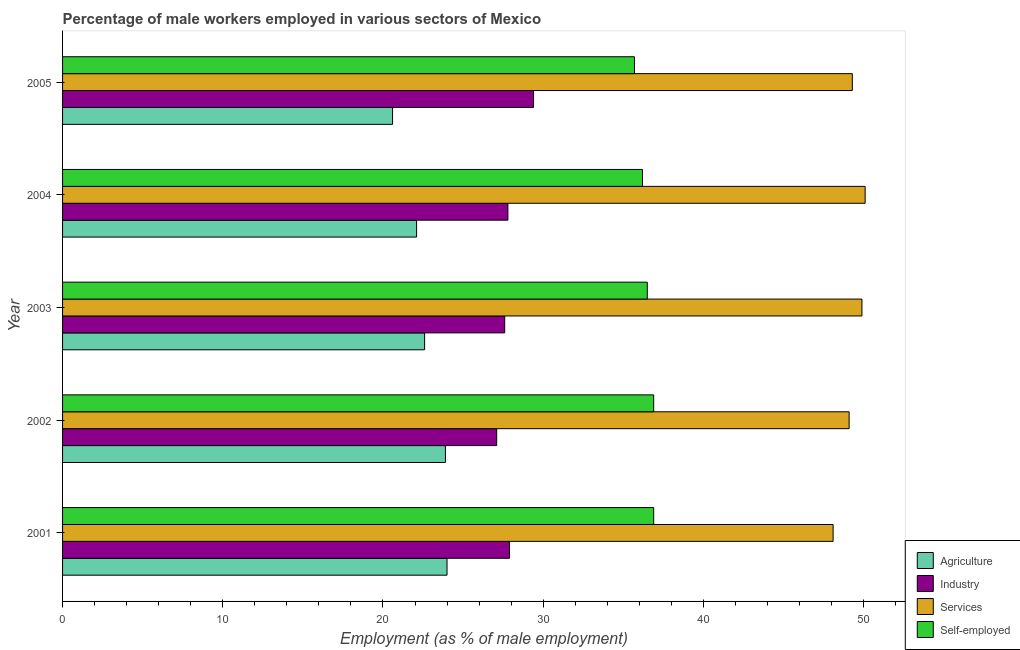How many groups of bars are there?
Provide a short and direct response. 5. Are the number of bars on each tick of the Y-axis equal?
Provide a succinct answer. Yes. What is the label of the 1st group of bars from the top?
Keep it short and to the point. 2005. What is the percentage of self employed male workers in 2004?
Make the answer very short. 36.2. Across all years, what is the minimum percentage of self employed male workers?
Your response must be concise. 35.7. In which year was the percentage of male workers in agriculture minimum?
Give a very brief answer. 2005. What is the total percentage of male workers in services in the graph?
Give a very brief answer. 246.5. What is the difference between the percentage of self employed male workers in 2001 and that in 2005?
Make the answer very short. 1.2. What is the difference between the percentage of male workers in industry in 2005 and the percentage of self employed male workers in 2004?
Offer a terse response. -6.8. What is the average percentage of self employed male workers per year?
Provide a succinct answer. 36.44. What is the ratio of the percentage of male workers in industry in 2001 to that in 2002?
Provide a succinct answer. 1.03. Is the percentage of male workers in services in 2003 less than that in 2004?
Your answer should be very brief. Yes. Is the difference between the percentage of male workers in services in 2001 and 2002 greater than the difference between the percentage of self employed male workers in 2001 and 2002?
Your response must be concise. No. What is the difference between the highest and the lowest percentage of male workers in services?
Your response must be concise. 2. In how many years, is the percentage of self employed male workers greater than the average percentage of self employed male workers taken over all years?
Give a very brief answer. 3. What does the 3rd bar from the top in 2001 represents?
Your answer should be very brief. Industry. What does the 1st bar from the bottom in 2003 represents?
Your answer should be very brief. Agriculture. Is it the case that in every year, the sum of the percentage of male workers in agriculture and percentage of male workers in industry is greater than the percentage of male workers in services?
Your response must be concise. No. Are all the bars in the graph horizontal?
Your answer should be very brief. Yes. Are the values on the major ticks of X-axis written in scientific E-notation?
Provide a short and direct response. No. Where does the legend appear in the graph?
Offer a very short reply. Bottom right. What is the title of the graph?
Ensure brevity in your answer.  Percentage of male workers employed in various sectors of Mexico. Does "Plant species" appear as one of the legend labels in the graph?
Keep it short and to the point. No. What is the label or title of the X-axis?
Offer a terse response. Employment (as % of male employment). What is the label or title of the Y-axis?
Your answer should be very brief. Year. What is the Employment (as % of male employment) in Agriculture in 2001?
Offer a very short reply. 24. What is the Employment (as % of male employment) in Industry in 2001?
Offer a terse response. 27.9. What is the Employment (as % of male employment) of Services in 2001?
Make the answer very short. 48.1. What is the Employment (as % of male employment) of Self-employed in 2001?
Provide a short and direct response. 36.9. What is the Employment (as % of male employment) in Agriculture in 2002?
Your answer should be very brief. 23.9. What is the Employment (as % of male employment) in Industry in 2002?
Provide a succinct answer. 27.1. What is the Employment (as % of male employment) in Services in 2002?
Ensure brevity in your answer.  49.1. What is the Employment (as % of male employment) in Self-employed in 2002?
Provide a succinct answer. 36.9. What is the Employment (as % of male employment) of Agriculture in 2003?
Give a very brief answer. 22.6. What is the Employment (as % of male employment) in Industry in 2003?
Make the answer very short. 27.6. What is the Employment (as % of male employment) in Services in 2003?
Keep it short and to the point. 49.9. What is the Employment (as % of male employment) of Self-employed in 2003?
Ensure brevity in your answer.  36.5. What is the Employment (as % of male employment) of Agriculture in 2004?
Your answer should be very brief. 22.1. What is the Employment (as % of male employment) in Industry in 2004?
Ensure brevity in your answer.  27.8. What is the Employment (as % of male employment) of Services in 2004?
Your response must be concise. 50.1. What is the Employment (as % of male employment) of Self-employed in 2004?
Your response must be concise. 36.2. What is the Employment (as % of male employment) in Agriculture in 2005?
Keep it short and to the point. 20.6. What is the Employment (as % of male employment) in Industry in 2005?
Your answer should be compact. 29.4. What is the Employment (as % of male employment) in Services in 2005?
Your answer should be compact. 49.3. What is the Employment (as % of male employment) in Self-employed in 2005?
Provide a succinct answer. 35.7. Across all years, what is the maximum Employment (as % of male employment) in Industry?
Offer a terse response. 29.4. Across all years, what is the maximum Employment (as % of male employment) in Services?
Your answer should be compact. 50.1. Across all years, what is the maximum Employment (as % of male employment) of Self-employed?
Provide a short and direct response. 36.9. Across all years, what is the minimum Employment (as % of male employment) of Agriculture?
Offer a terse response. 20.6. Across all years, what is the minimum Employment (as % of male employment) of Industry?
Give a very brief answer. 27.1. Across all years, what is the minimum Employment (as % of male employment) of Services?
Make the answer very short. 48.1. Across all years, what is the minimum Employment (as % of male employment) of Self-employed?
Make the answer very short. 35.7. What is the total Employment (as % of male employment) in Agriculture in the graph?
Keep it short and to the point. 113.2. What is the total Employment (as % of male employment) of Industry in the graph?
Give a very brief answer. 139.8. What is the total Employment (as % of male employment) in Services in the graph?
Your response must be concise. 246.5. What is the total Employment (as % of male employment) of Self-employed in the graph?
Keep it short and to the point. 182.2. What is the difference between the Employment (as % of male employment) in Agriculture in 2001 and that in 2002?
Keep it short and to the point. 0.1. What is the difference between the Employment (as % of male employment) in Services in 2001 and that in 2002?
Make the answer very short. -1. What is the difference between the Employment (as % of male employment) of Self-employed in 2001 and that in 2002?
Offer a terse response. 0. What is the difference between the Employment (as % of male employment) in Industry in 2001 and that in 2003?
Make the answer very short. 0.3. What is the difference between the Employment (as % of male employment) in Services in 2001 and that in 2003?
Offer a terse response. -1.8. What is the difference between the Employment (as % of male employment) in Self-employed in 2001 and that in 2004?
Make the answer very short. 0.7. What is the difference between the Employment (as % of male employment) in Agriculture in 2001 and that in 2005?
Offer a very short reply. 3.4. What is the difference between the Employment (as % of male employment) of Industry in 2001 and that in 2005?
Keep it short and to the point. -1.5. What is the difference between the Employment (as % of male employment) of Services in 2001 and that in 2005?
Provide a short and direct response. -1.2. What is the difference between the Employment (as % of male employment) in Self-employed in 2001 and that in 2005?
Offer a terse response. 1.2. What is the difference between the Employment (as % of male employment) of Agriculture in 2002 and that in 2003?
Offer a terse response. 1.3. What is the difference between the Employment (as % of male employment) in Services in 2002 and that in 2003?
Provide a succinct answer. -0.8. What is the difference between the Employment (as % of male employment) in Self-employed in 2002 and that in 2004?
Your answer should be compact. 0.7. What is the difference between the Employment (as % of male employment) of Industry in 2002 and that in 2005?
Your response must be concise. -2.3. What is the difference between the Employment (as % of male employment) in Self-employed in 2002 and that in 2005?
Give a very brief answer. 1.2. What is the difference between the Employment (as % of male employment) in Industry in 2003 and that in 2004?
Provide a short and direct response. -0.2. What is the difference between the Employment (as % of male employment) in Services in 2003 and that in 2004?
Provide a short and direct response. -0.2. What is the difference between the Employment (as % of male employment) of Self-employed in 2003 and that in 2004?
Your answer should be compact. 0.3. What is the difference between the Employment (as % of male employment) of Agriculture in 2003 and that in 2005?
Your response must be concise. 2. What is the difference between the Employment (as % of male employment) of Self-employed in 2003 and that in 2005?
Make the answer very short. 0.8. What is the difference between the Employment (as % of male employment) in Agriculture in 2004 and that in 2005?
Make the answer very short. 1.5. What is the difference between the Employment (as % of male employment) in Industry in 2004 and that in 2005?
Provide a short and direct response. -1.6. What is the difference between the Employment (as % of male employment) in Self-employed in 2004 and that in 2005?
Your answer should be compact. 0.5. What is the difference between the Employment (as % of male employment) of Agriculture in 2001 and the Employment (as % of male employment) of Services in 2002?
Offer a terse response. -25.1. What is the difference between the Employment (as % of male employment) of Agriculture in 2001 and the Employment (as % of male employment) of Self-employed in 2002?
Your response must be concise. -12.9. What is the difference between the Employment (as % of male employment) in Industry in 2001 and the Employment (as % of male employment) in Services in 2002?
Keep it short and to the point. -21.2. What is the difference between the Employment (as % of male employment) of Agriculture in 2001 and the Employment (as % of male employment) of Industry in 2003?
Offer a terse response. -3.6. What is the difference between the Employment (as % of male employment) of Agriculture in 2001 and the Employment (as % of male employment) of Services in 2003?
Your answer should be very brief. -25.9. What is the difference between the Employment (as % of male employment) in Agriculture in 2001 and the Employment (as % of male employment) in Self-employed in 2003?
Your answer should be compact. -12.5. What is the difference between the Employment (as % of male employment) of Industry in 2001 and the Employment (as % of male employment) of Services in 2003?
Offer a terse response. -22. What is the difference between the Employment (as % of male employment) of Services in 2001 and the Employment (as % of male employment) of Self-employed in 2003?
Keep it short and to the point. 11.6. What is the difference between the Employment (as % of male employment) in Agriculture in 2001 and the Employment (as % of male employment) in Industry in 2004?
Provide a succinct answer. -3.8. What is the difference between the Employment (as % of male employment) of Agriculture in 2001 and the Employment (as % of male employment) of Services in 2004?
Give a very brief answer. -26.1. What is the difference between the Employment (as % of male employment) in Agriculture in 2001 and the Employment (as % of male employment) in Self-employed in 2004?
Your answer should be compact. -12.2. What is the difference between the Employment (as % of male employment) in Industry in 2001 and the Employment (as % of male employment) in Services in 2004?
Your response must be concise. -22.2. What is the difference between the Employment (as % of male employment) in Industry in 2001 and the Employment (as % of male employment) in Self-employed in 2004?
Provide a succinct answer. -8.3. What is the difference between the Employment (as % of male employment) of Services in 2001 and the Employment (as % of male employment) of Self-employed in 2004?
Provide a short and direct response. 11.9. What is the difference between the Employment (as % of male employment) in Agriculture in 2001 and the Employment (as % of male employment) in Services in 2005?
Your response must be concise. -25.3. What is the difference between the Employment (as % of male employment) of Agriculture in 2001 and the Employment (as % of male employment) of Self-employed in 2005?
Offer a terse response. -11.7. What is the difference between the Employment (as % of male employment) in Industry in 2001 and the Employment (as % of male employment) in Services in 2005?
Your response must be concise. -21.4. What is the difference between the Employment (as % of male employment) in Agriculture in 2002 and the Employment (as % of male employment) in Industry in 2003?
Your response must be concise. -3.7. What is the difference between the Employment (as % of male employment) in Agriculture in 2002 and the Employment (as % of male employment) in Services in 2003?
Provide a short and direct response. -26. What is the difference between the Employment (as % of male employment) of Industry in 2002 and the Employment (as % of male employment) of Services in 2003?
Your answer should be very brief. -22.8. What is the difference between the Employment (as % of male employment) of Agriculture in 2002 and the Employment (as % of male employment) of Services in 2004?
Make the answer very short. -26.2. What is the difference between the Employment (as % of male employment) of Industry in 2002 and the Employment (as % of male employment) of Self-employed in 2004?
Your answer should be very brief. -9.1. What is the difference between the Employment (as % of male employment) of Agriculture in 2002 and the Employment (as % of male employment) of Industry in 2005?
Offer a terse response. -5.5. What is the difference between the Employment (as % of male employment) of Agriculture in 2002 and the Employment (as % of male employment) of Services in 2005?
Your answer should be compact. -25.4. What is the difference between the Employment (as % of male employment) of Agriculture in 2002 and the Employment (as % of male employment) of Self-employed in 2005?
Give a very brief answer. -11.8. What is the difference between the Employment (as % of male employment) in Industry in 2002 and the Employment (as % of male employment) in Services in 2005?
Give a very brief answer. -22.2. What is the difference between the Employment (as % of male employment) in Industry in 2002 and the Employment (as % of male employment) in Self-employed in 2005?
Ensure brevity in your answer.  -8.6. What is the difference between the Employment (as % of male employment) of Agriculture in 2003 and the Employment (as % of male employment) of Services in 2004?
Offer a terse response. -27.5. What is the difference between the Employment (as % of male employment) in Industry in 2003 and the Employment (as % of male employment) in Services in 2004?
Your answer should be very brief. -22.5. What is the difference between the Employment (as % of male employment) in Agriculture in 2003 and the Employment (as % of male employment) in Services in 2005?
Provide a short and direct response. -26.7. What is the difference between the Employment (as % of male employment) in Agriculture in 2003 and the Employment (as % of male employment) in Self-employed in 2005?
Offer a very short reply. -13.1. What is the difference between the Employment (as % of male employment) in Industry in 2003 and the Employment (as % of male employment) in Services in 2005?
Give a very brief answer. -21.7. What is the difference between the Employment (as % of male employment) in Industry in 2003 and the Employment (as % of male employment) in Self-employed in 2005?
Provide a succinct answer. -8.1. What is the difference between the Employment (as % of male employment) in Agriculture in 2004 and the Employment (as % of male employment) in Industry in 2005?
Provide a succinct answer. -7.3. What is the difference between the Employment (as % of male employment) of Agriculture in 2004 and the Employment (as % of male employment) of Services in 2005?
Make the answer very short. -27.2. What is the difference between the Employment (as % of male employment) in Agriculture in 2004 and the Employment (as % of male employment) in Self-employed in 2005?
Ensure brevity in your answer.  -13.6. What is the difference between the Employment (as % of male employment) in Industry in 2004 and the Employment (as % of male employment) in Services in 2005?
Provide a succinct answer. -21.5. What is the difference between the Employment (as % of male employment) of Industry in 2004 and the Employment (as % of male employment) of Self-employed in 2005?
Provide a short and direct response. -7.9. What is the difference between the Employment (as % of male employment) of Services in 2004 and the Employment (as % of male employment) of Self-employed in 2005?
Your answer should be very brief. 14.4. What is the average Employment (as % of male employment) of Agriculture per year?
Offer a very short reply. 22.64. What is the average Employment (as % of male employment) of Industry per year?
Ensure brevity in your answer.  27.96. What is the average Employment (as % of male employment) of Services per year?
Provide a short and direct response. 49.3. What is the average Employment (as % of male employment) in Self-employed per year?
Your answer should be very brief. 36.44. In the year 2001, what is the difference between the Employment (as % of male employment) of Agriculture and Employment (as % of male employment) of Industry?
Keep it short and to the point. -3.9. In the year 2001, what is the difference between the Employment (as % of male employment) in Agriculture and Employment (as % of male employment) in Services?
Provide a short and direct response. -24.1. In the year 2001, what is the difference between the Employment (as % of male employment) of Industry and Employment (as % of male employment) of Services?
Keep it short and to the point. -20.2. In the year 2001, what is the difference between the Employment (as % of male employment) of Services and Employment (as % of male employment) of Self-employed?
Your answer should be compact. 11.2. In the year 2002, what is the difference between the Employment (as % of male employment) of Agriculture and Employment (as % of male employment) of Services?
Your answer should be very brief. -25.2. In the year 2002, what is the difference between the Employment (as % of male employment) in Industry and Employment (as % of male employment) in Services?
Keep it short and to the point. -22. In the year 2002, what is the difference between the Employment (as % of male employment) of Industry and Employment (as % of male employment) of Self-employed?
Offer a very short reply. -9.8. In the year 2002, what is the difference between the Employment (as % of male employment) of Services and Employment (as % of male employment) of Self-employed?
Offer a terse response. 12.2. In the year 2003, what is the difference between the Employment (as % of male employment) in Agriculture and Employment (as % of male employment) in Industry?
Keep it short and to the point. -5. In the year 2003, what is the difference between the Employment (as % of male employment) in Agriculture and Employment (as % of male employment) in Services?
Offer a very short reply. -27.3. In the year 2003, what is the difference between the Employment (as % of male employment) of Industry and Employment (as % of male employment) of Services?
Ensure brevity in your answer.  -22.3. In the year 2003, what is the difference between the Employment (as % of male employment) of Industry and Employment (as % of male employment) of Self-employed?
Ensure brevity in your answer.  -8.9. In the year 2004, what is the difference between the Employment (as % of male employment) of Agriculture and Employment (as % of male employment) of Self-employed?
Give a very brief answer. -14.1. In the year 2004, what is the difference between the Employment (as % of male employment) of Industry and Employment (as % of male employment) of Services?
Your response must be concise. -22.3. In the year 2004, what is the difference between the Employment (as % of male employment) in Industry and Employment (as % of male employment) in Self-employed?
Keep it short and to the point. -8.4. In the year 2004, what is the difference between the Employment (as % of male employment) of Services and Employment (as % of male employment) of Self-employed?
Give a very brief answer. 13.9. In the year 2005, what is the difference between the Employment (as % of male employment) of Agriculture and Employment (as % of male employment) of Services?
Offer a very short reply. -28.7. In the year 2005, what is the difference between the Employment (as % of male employment) of Agriculture and Employment (as % of male employment) of Self-employed?
Ensure brevity in your answer.  -15.1. In the year 2005, what is the difference between the Employment (as % of male employment) in Industry and Employment (as % of male employment) in Services?
Your answer should be compact. -19.9. What is the ratio of the Employment (as % of male employment) in Industry in 2001 to that in 2002?
Give a very brief answer. 1.03. What is the ratio of the Employment (as % of male employment) in Services in 2001 to that in 2002?
Your answer should be compact. 0.98. What is the ratio of the Employment (as % of male employment) in Agriculture in 2001 to that in 2003?
Keep it short and to the point. 1.06. What is the ratio of the Employment (as % of male employment) of Industry in 2001 to that in 2003?
Provide a short and direct response. 1.01. What is the ratio of the Employment (as % of male employment) of Services in 2001 to that in 2003?
Give a very brief answer. 0.96. What is the ratio of the Employment (as % of male employment) in Self-employed in 2001 to that in 2003?
Ensure brevity in your answer.  1.01. What is the ratio of the Employment (as % of male employment) in Agriculture in 2001 to that in 2004?
Make the answer very short. 1.09. What is the ratio of the Employment (as % of male employment) in Industry in 2001 to that in 2004?
Provide a succinct answer. 1. What is the ratio of the Employment (as % of male employment) in Services in 2001 to that in 2004?
Give a very brief answer. 0.96. What is the ratio of the Employment (as % of male employment) in Self-employed in 2001 to that in 2004?
Make the answer very short. 1.02. What is the ratio of the Employment (as % of male employment) of Agriculture in 2001 to that in 2005?
Your response must be concise. 1.17. What is the ratio of the Employment (as % of male employment) of Industry in 2001 to that in 2005?
Your answer should be very brief. 0.95. What is the ratio of the Employment (as % of male employment) in Services in 2001 to that in 2005?
Ensure brevity in your answer.  0.98. What is the ratio of the Employment (as % of male employment) of Self-employed in 2001 to that in 2005?
Your answer should be compact. 1.03. What is the ratio of the Employment (as % of male employment) of Agriculture in 2002 to that in 2003?
Provide a succinct answer. 1.06. What is the ratio of the Employment (as % of male employment) of Industry in 2002 to that in 2003?
Your answer should be very brief. 0.98. What is the ratio of the Employment (as % of male employment) in Agriculture in 2002 to that in 2004?
Your response must be concise. 1.08. What is the ratio of the Employment (as % of male employment) of Industry in 2002 to that in 2004?
Offer a terse response. 0.97. What is the ratio of the Employment (as % of male employment) in Self-employed in 2002 to that in 2004?
Your answer should be very brief. 1.02. What is the ratio of the Employment (as % of male employment) of Agriculture in 2002 to that in 2005?
Your answer should be very brief. 1.16. What is the ratio of the Employment (as % of male employment) in Industry in 2002 to that in 2005?
Your response must be concise. 0.92. What is the ratio of the Employment (as % of male employment) in Services in 2002 to that in 2005?
Provide a short and direct response. 1. What is the ratio of the Employment (as % of male employment) in Self-employed in 2002 to that in 2005?
Offer a very short reply. 1.03. What is the ratio of the Employment (as % of male employment) of Agriculture in 2003 to that in 2004?
Keep it short and to the point. 1.02. What is the ratio of the Employment (as % of male employment) of Self-employed in 2003 to that in 2004?
Make the answer very short. 1.01. What is the ratio of the Employment (as % of male employment) in Agriculture in 2003 to that in 2005?
Ensure brevity in your answer.  1.1. What is the ratio of the Employment (as % of male employment) in Industry in 2003 to that in 2005?
Keep it short and to the point. 0.94. What is the ratio of the Employment (as % of male employment) of Services in 2003 to that in 2005?
Your answer should be very brief. 1.01. What is the ratio of the Employment (as % of male employment) of Self-employed in 2003 to that in 2005?
Keep it short and to the point. 1.02. What is the ratio of the Employment (as % of male employment) in Agriculture in 2004 to that in 2005?
Provide a short and direct response. 1.07. What is the ratio of the Employment (as % of male employment) in Industry in 2004 to that in 2005?
Keep it short and to the point. 0.95. What is the ratio of the Employment (as % of male employment) in Services in 2004 to that in 2005?
Give a very brief answer. 1.02. What is the ratio of the Employment (as % of male employment) in Self-employed in 2004 to that in 2005?
Your answer should be very brief. 1.01. What is the difference between the highest and the second highest Employment (as % of male employment) of Agriculture?
Give a very brief answer. 0.1. What is the difference between the highest and the second highest Employment (as % of male employment) of Industry?
Give a very brief answer. 1.5. What is the difference between the highest and the second highest Employment (as % of male employment) in Services?
Ensure brevity in your answer.  0.2. What is the difference between the highest and the lowest Employment (as % of male employment) in Agriculture?
Offer a terse response. 3.4. What is the difference between the highest and the lowest Employment (as % of male employment) in Industry?
Your answer should be very brief. 2.3. What is the difference between the highest and the lowest Employment (as % of male employment) in Services?
Provide a short and direct response. 2. What is the difference between the highest and the lowest Employment (as % of male employment) of Self-employed?
Offer a very short reply. 1.2. 